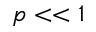<formula> <loc_0><loc_0><loc_500><loc_500>p < < 1</formula> 